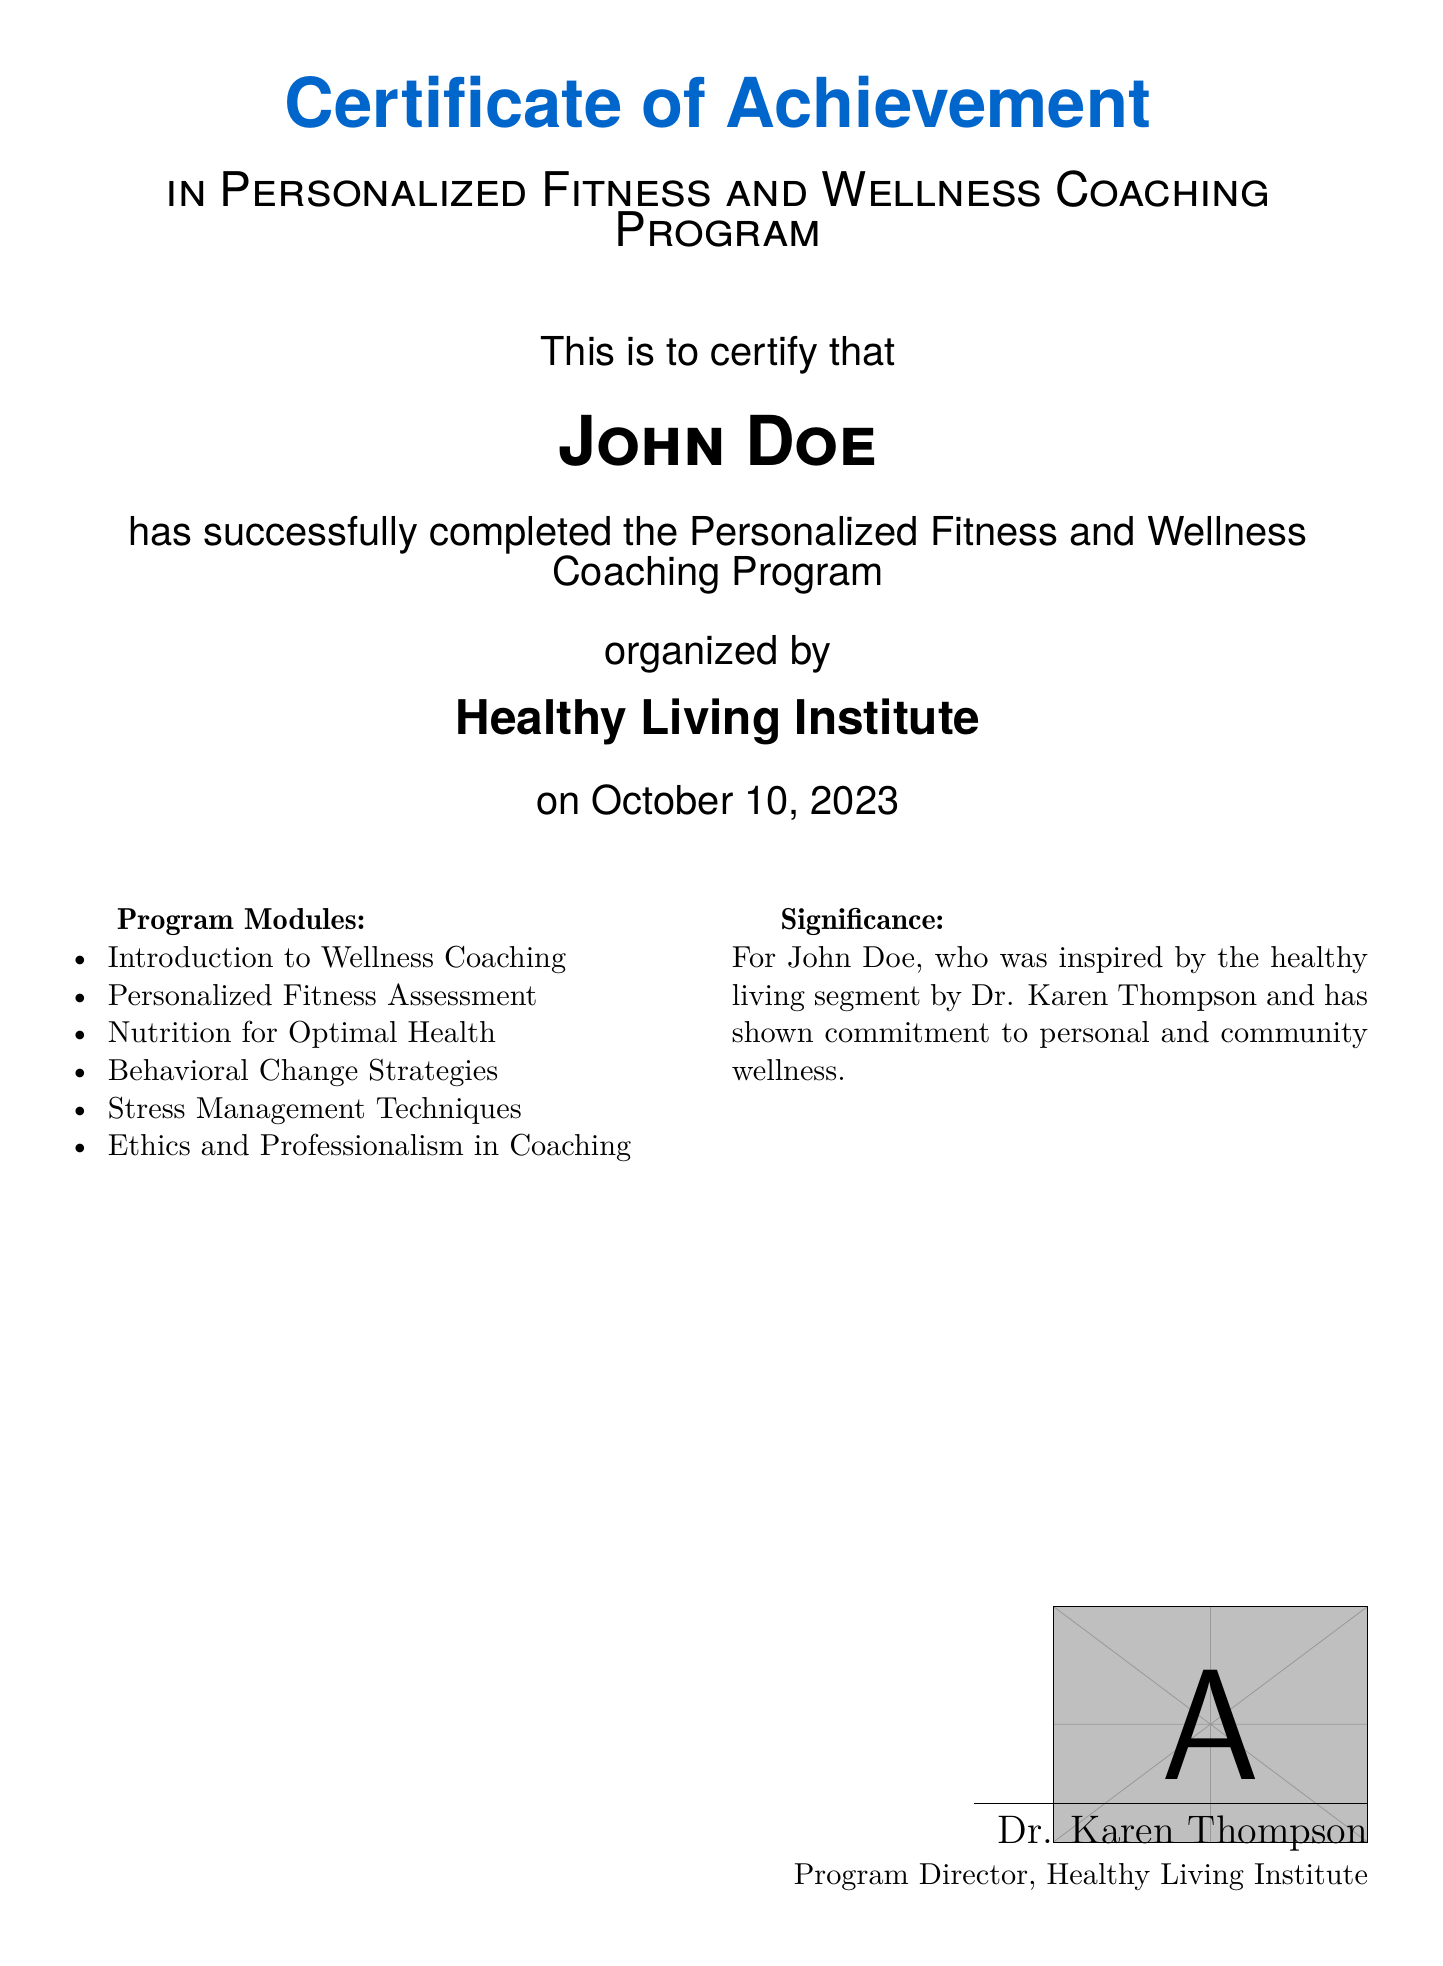What is the name of the program? The name of the program is listed in the document as the Personalized Fitness and Wellness Coaching Program.
Answer: Personalized Fitness and Wellness Coaching Program Who issued the certificate? The certificate was issued by the Healthy Living Institute as stated in the document.
Answer: Healthy Living Institute What is the certificate recipient's name? The recipient's name is prominently displayed in the certificate.
Answer: John Doe On what date was the program completed? The completion date is clearly mentioned in the document.
Answer: October 10, 2023 How many program modules are listed? The document lists multiple program modules, totaling to six.
Answer: 6 What was the source of inspiration for John Doe? The source of inspiration is mentioned in the significance section of the document.
Answer: Dr. Karen Thompson Who signed the certificate? The document indicates who signed the certificate at the bottom.
Answer: Dr. Karen Thompson What subject covers nutrition in the program? This specific subject is included in the program modules section of the document.
Answer: Nutrition for Optimal Health What type of certificate is this? The title at the top of the document specifies this type of certificate.
Answer: Certificate of Achievement 